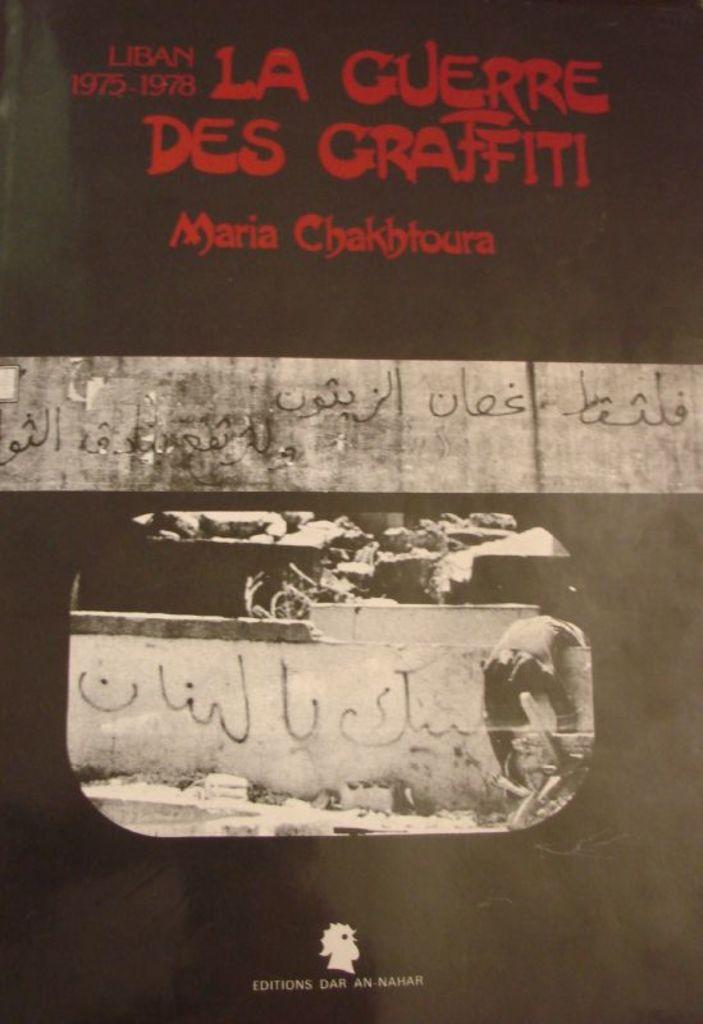Who is the author?
Provide a succinct answer. Maria chakhtoura. 